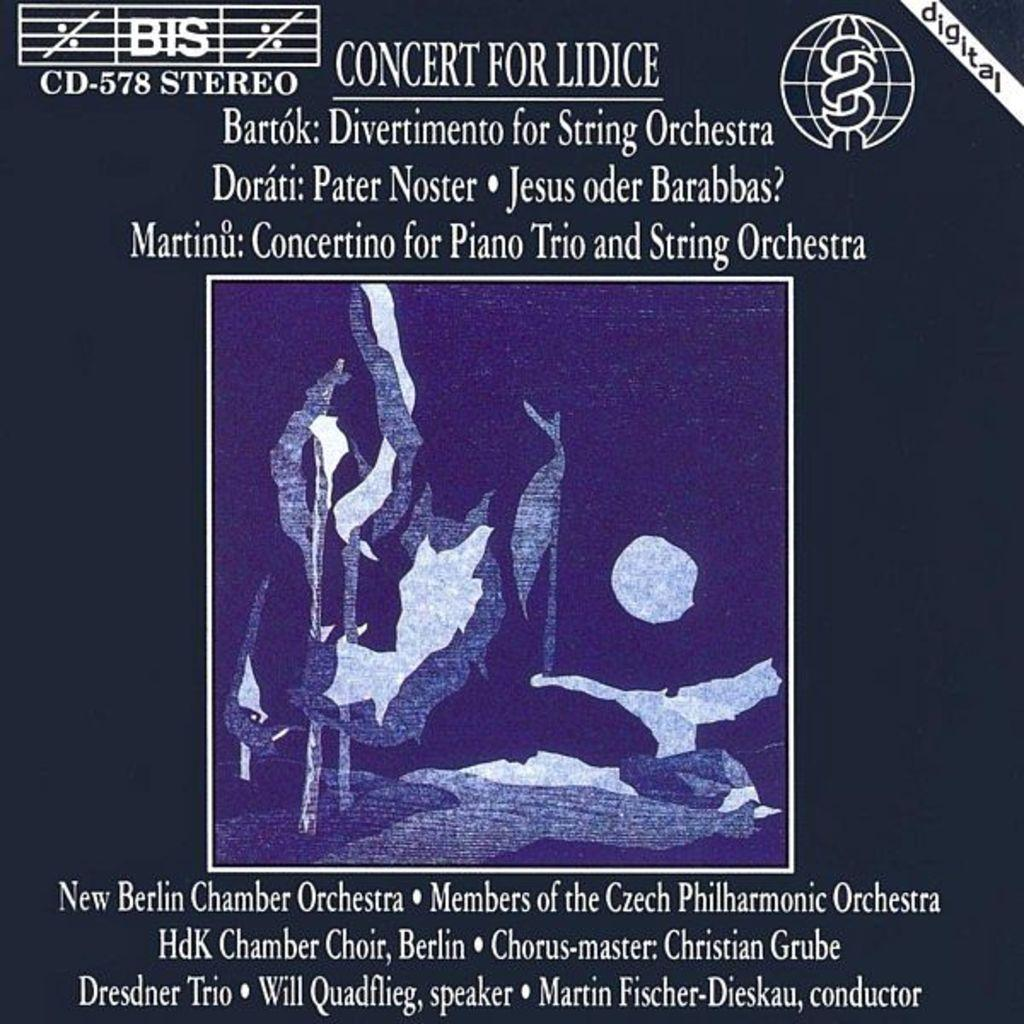<image>
Describe the image concisely. Poster titled Concert for Lidice that takes place at Concertino for Piano Trio and String Orchestra. 